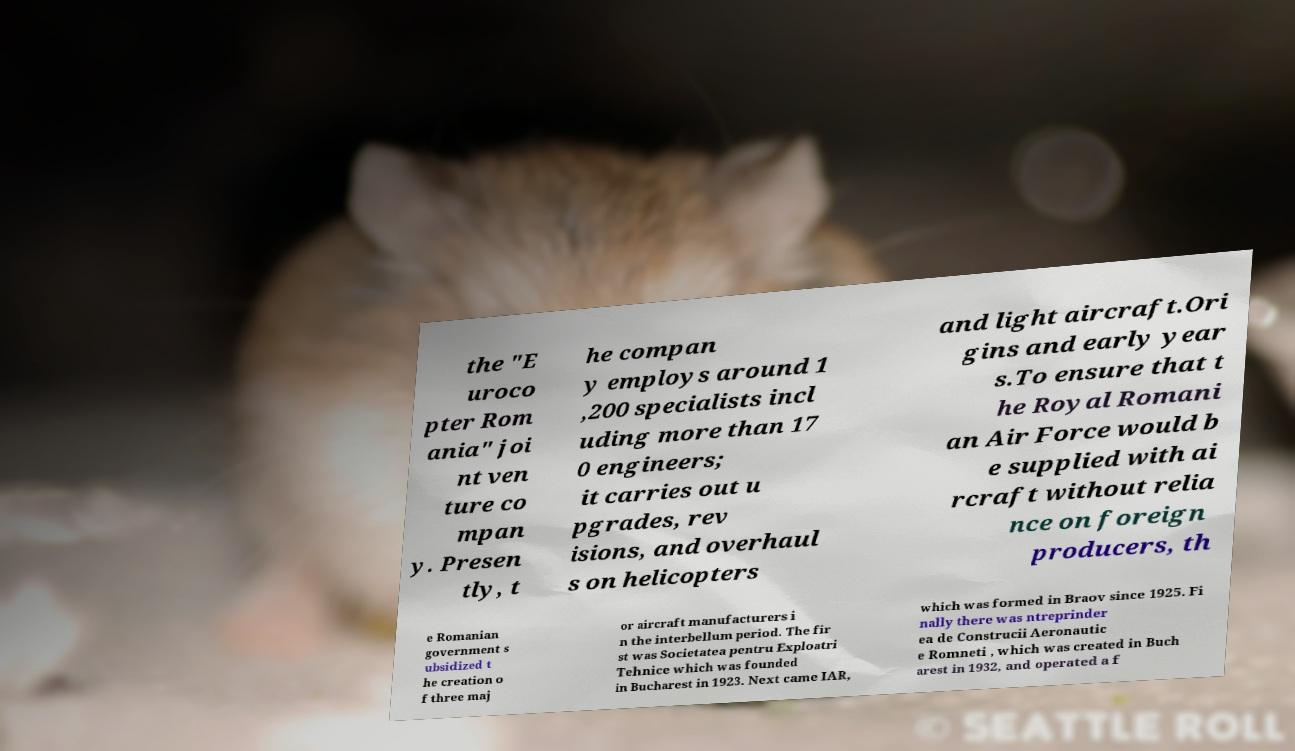What messages or text are displayed in this image? I need them in a readable, typed format. the "E uroco pter Rom ania" joi nt ven ture co mpan y. Presen tly, t he compan y employs around 1 ,200 specialists incl uding more than 17 0 engineers; it carries out u pgrades, rev isions, and overhaul s on helicopters and light aircraft.Ori gins and early year s.To ensure that t he Royal Romani an Air Force would b e supplied with ai rcraft without relia nce on foreign producers, th e Romanian government s ubsidized t he creation o f three maj or aircraft manufacturers i n the interbellum period. The fir st was Societatea pentru Exploatri Tehnice which was founded in Bucharest in 1923. Next came IAR, which was formed in Braov since 1925. Fi nally there was ntreprinder ea de Construcii Aeronautic e Romneti , which was created in Buch arest in 1932, and operated a f 